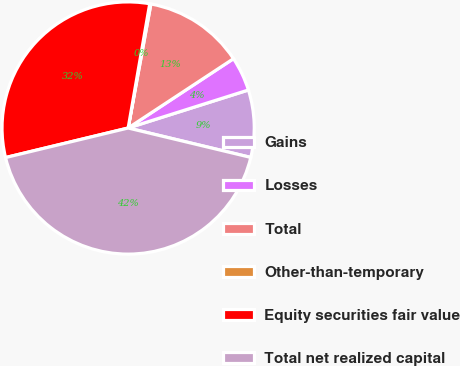Convert chart to OTSL. <chart><loc_0><loc_0><loc_500><loc_500><pie_chart><fcel>Gains<fcel>Losses<fcel>Total<fcel>Other-than-temporary<fcel>Equity securities fair value<fcel>Total net realized capital<nl><fcel>8.62%<fcel>4.39%<fcel>12.85%<fcel>0.15%<fcel>31.5%<fcel>42.49%<nl></chart> 